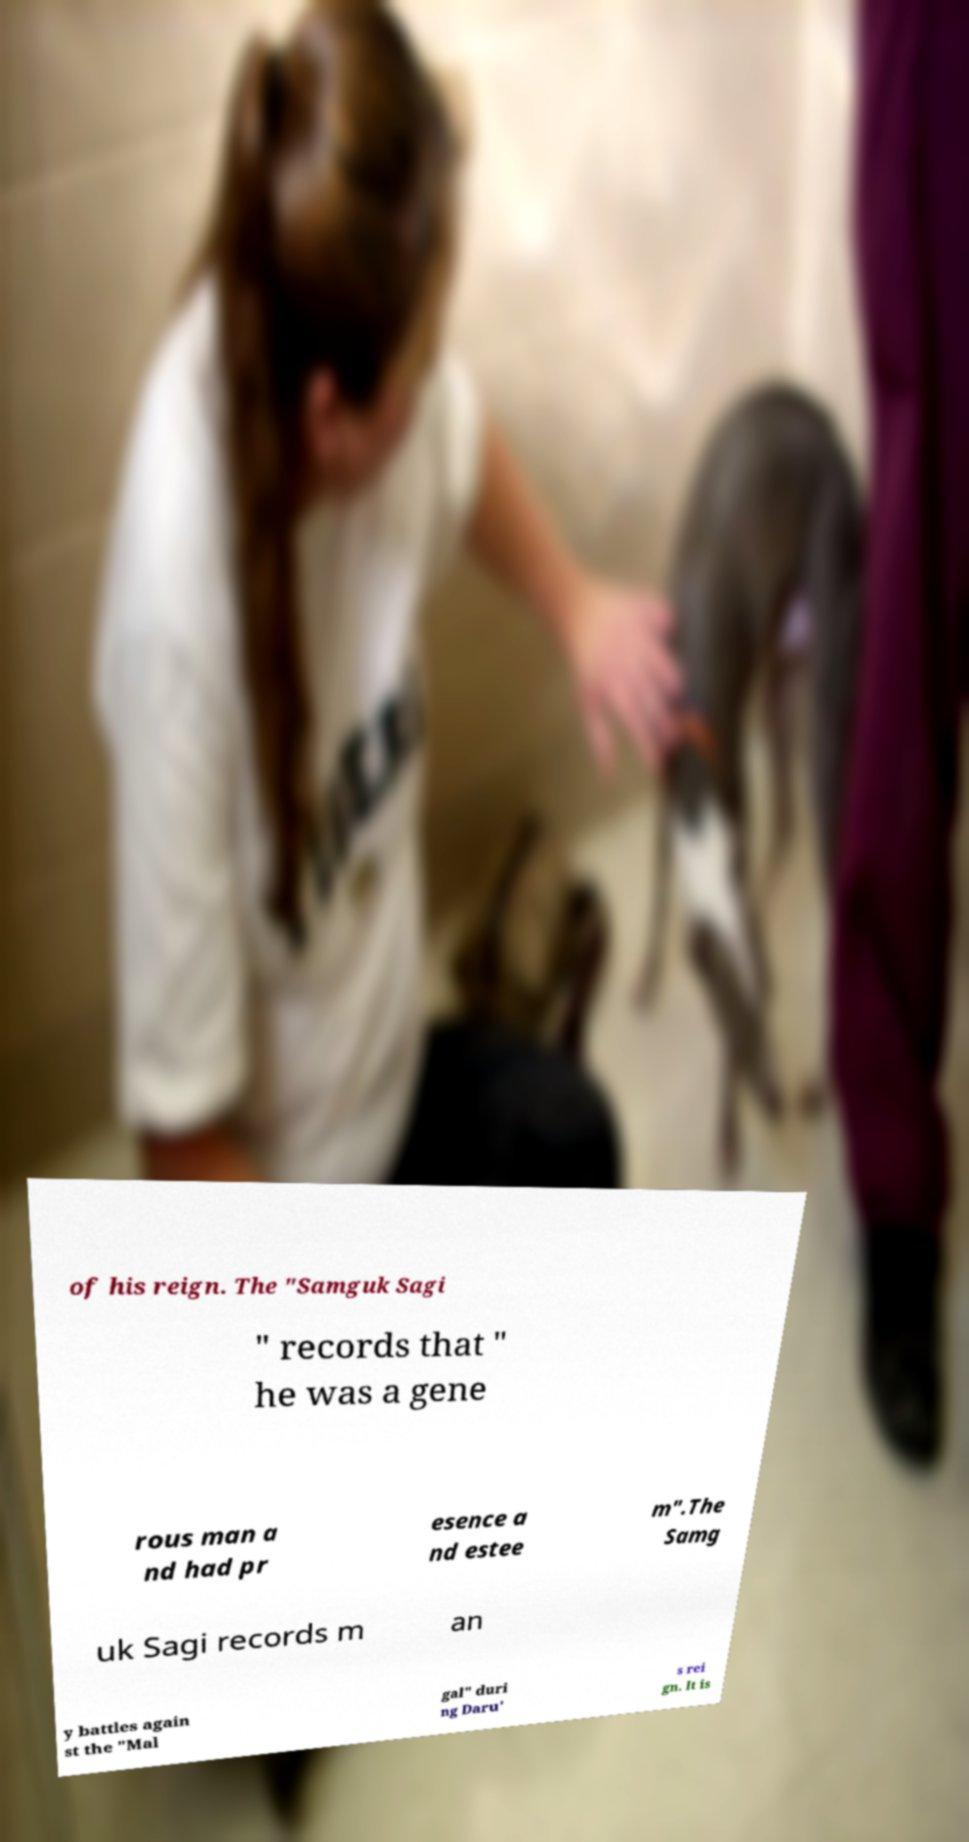For documentation purposes, I need the text within this image transcribed. Could you provide that? of his reign. The "Samguk Sagi " records that " he was a gene rous man a nd had pr esence a nd estee m".The Samg uk Sagi records m an y battles again st the "Mal gal" duri ng Daru' s rei gn. It is 